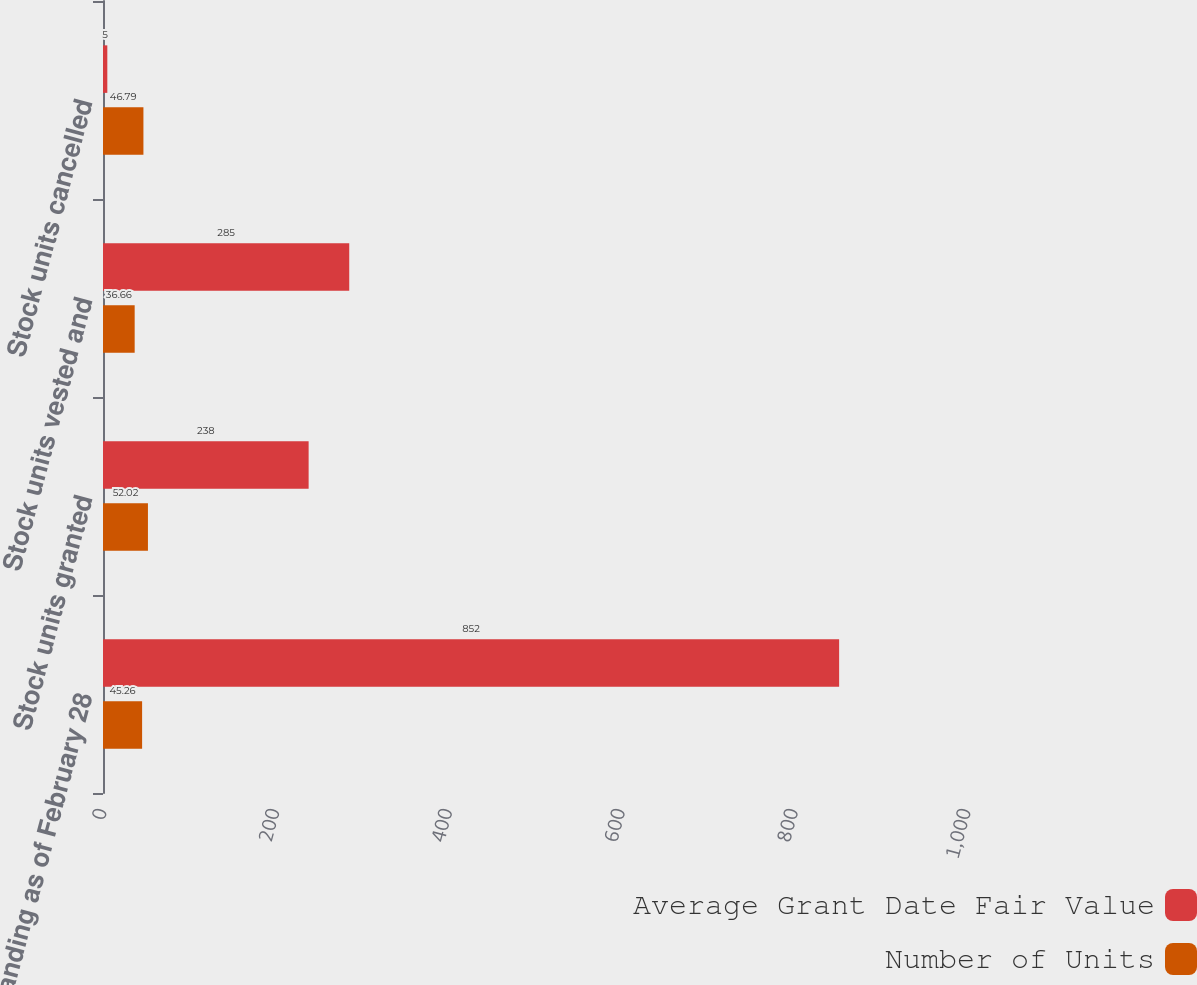Convert chart. <chart><loc_0><loc_0><loc_500><loc_500><stacked_bar_chart><ecel><fcel>Outstanding as of February 28<fcel>Stock units granted<fcel>Stock units vested and<fcel>Stock units cancelled<nl><fcel>Average Grant Date Fair Value<fcel>852<fcel>238<fcel>285<fcel>5<nl><fcel>Number of Units<fcel>45.26<fcel>52.02<fcel>36.66<fcel>46.79<nl></chart> 